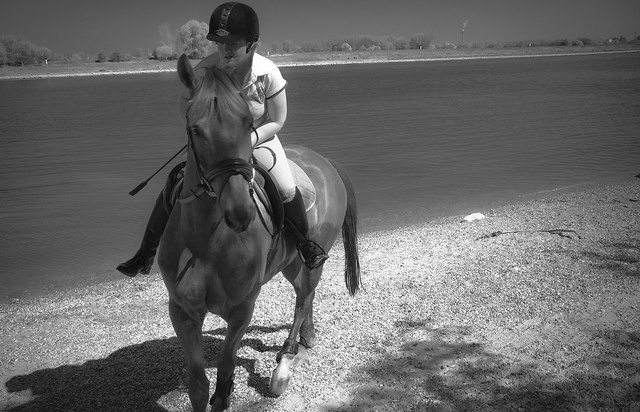Describe the objects in this image and their specific colors. I can see horse in gray, black, darkgray, and lightgray tones and people in gray, black, lightgray, and darkgray tones in this image. 